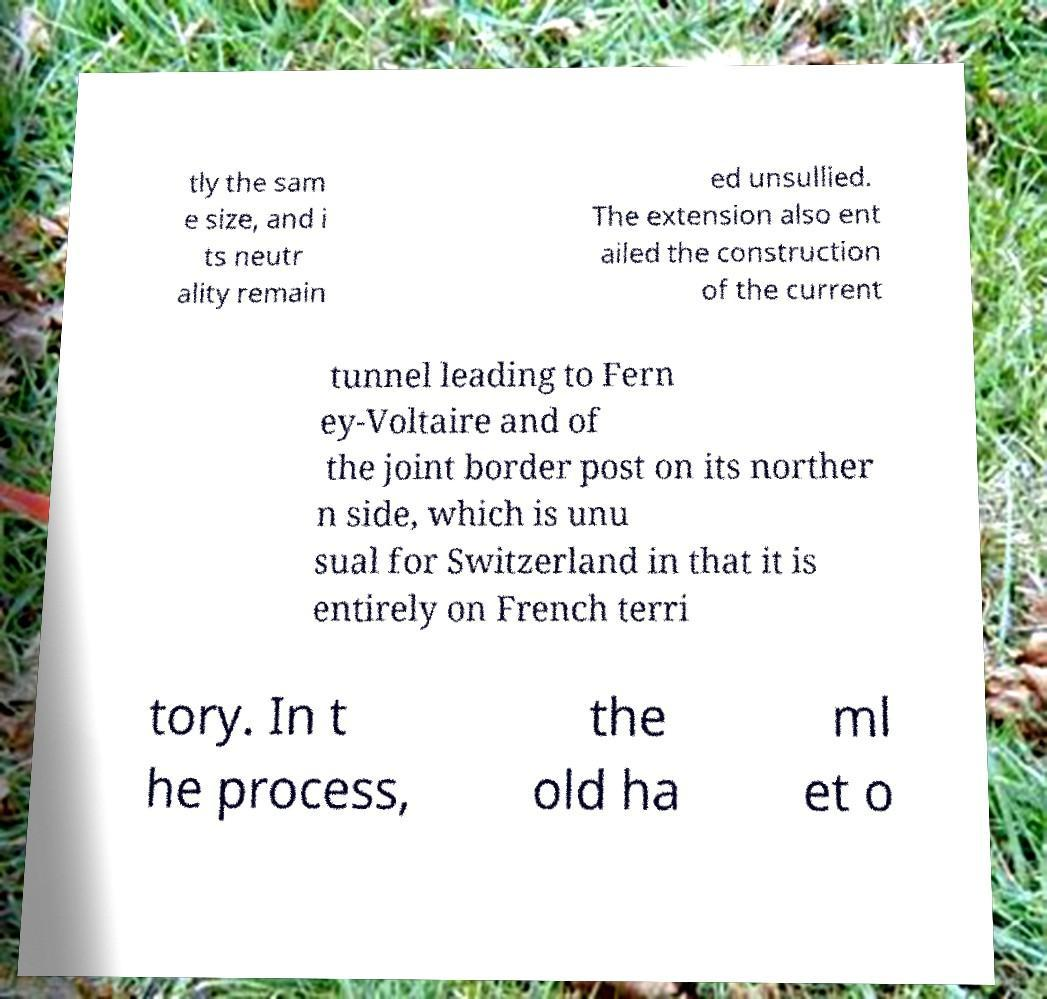For documentation purposes, I need the text within this image transcribed. Could you provide that? tly the sam e size, and i ts neutr ality remain ed unsullied. The extension also ent ailed the construction of the current tunnel leading to Fern ey-Voltaire and of the joint border post on its norther n side, which is unu sual for Switzerland in that it is entirely on French terri tory. In t he process, the old ha ml et o 